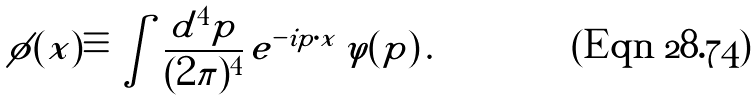<formula> <loc_0><loc_0><loc_500><loc_500>\phi ( x ) \equiv \int \frac { d ^ { 4 } p } { ( 2 \pi ) ^ { 4 } } \, e ^ { - i p \cdot x } \, \varphi ( p ) \, .</formula> 